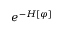<formula> <loc_0><loc_0><loc_500><loc_500>e ^ { - H [ \varphi ] }</formula> 